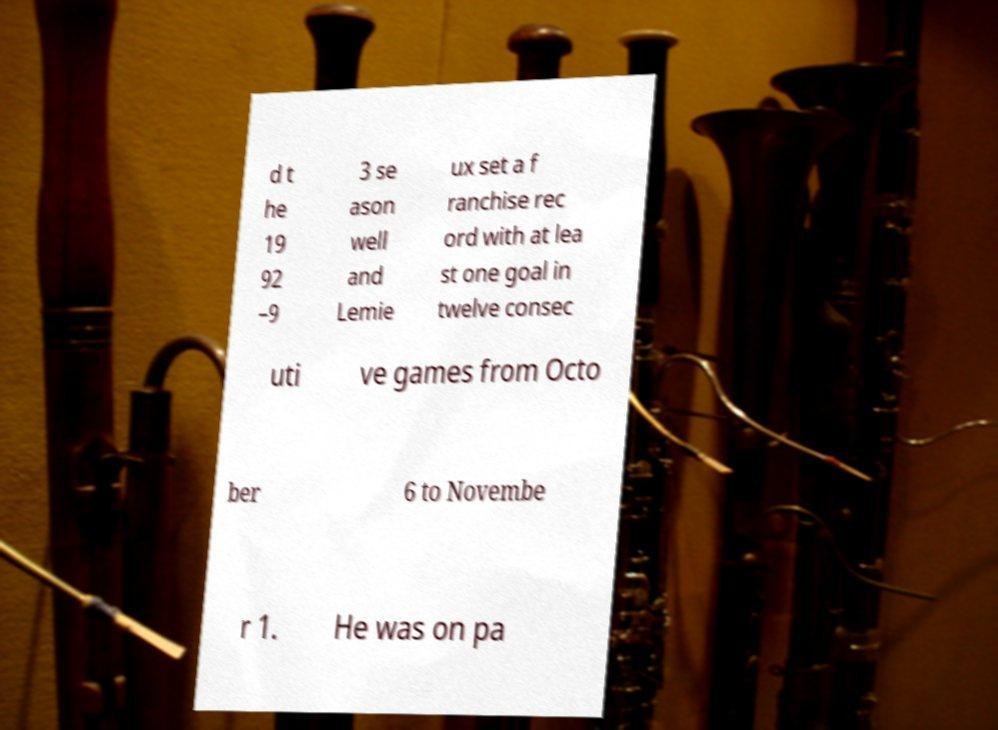Could you assist in decoding the text presented in this image and type it out clearly? d t he 19 92 –9 3 se ason well and Lemie ux set a f ranchise rec ord with at lea st one goal in twelve consec uti ve games from Octo ber 6 to Novembe r 1. He was on pa 